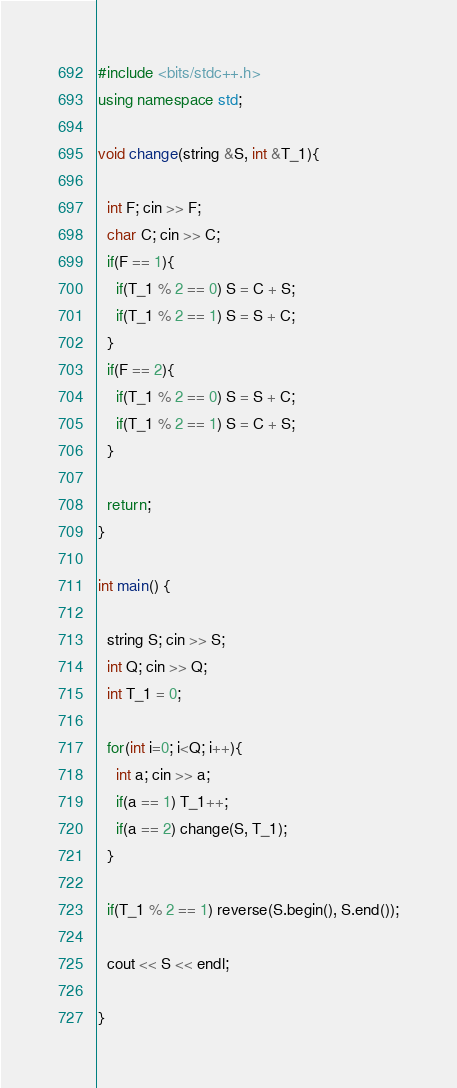Convert code to text. <code><loc_0><loc_0><loc_500><loc_500><_C++_>#include <bits/stdc++.h>
using namespace std;

void change(string &S, int &T_1){
  
  int F; cin >> F;
  char C; cin >> C;
  if(F == 1){
    if(T_1 % 2 == 0) S = C + S;
    if(T_1 % 2 == 1) S = S + C;
  }
  if(F == 2){
    if(T_1 % 2 == 0) S = S + C;
    if(T_1 % 2 == 1) S = C + S;
  }
  
  return;
}

int main() {
  
  string S; cin >> S;
  int Q; cin >> Q;
  int T_1 = 0;
  
  for(int i=0; i<Q; i++){
    int a; cin >> a;
    if(a == 1) T_1++;
    if(a == 2) change(S, T_1);
  }
  
  if(T_1 % 2 == 1) reverse(S.begin(), S.end());
  
  cout << S << endl;
  
}</code> 